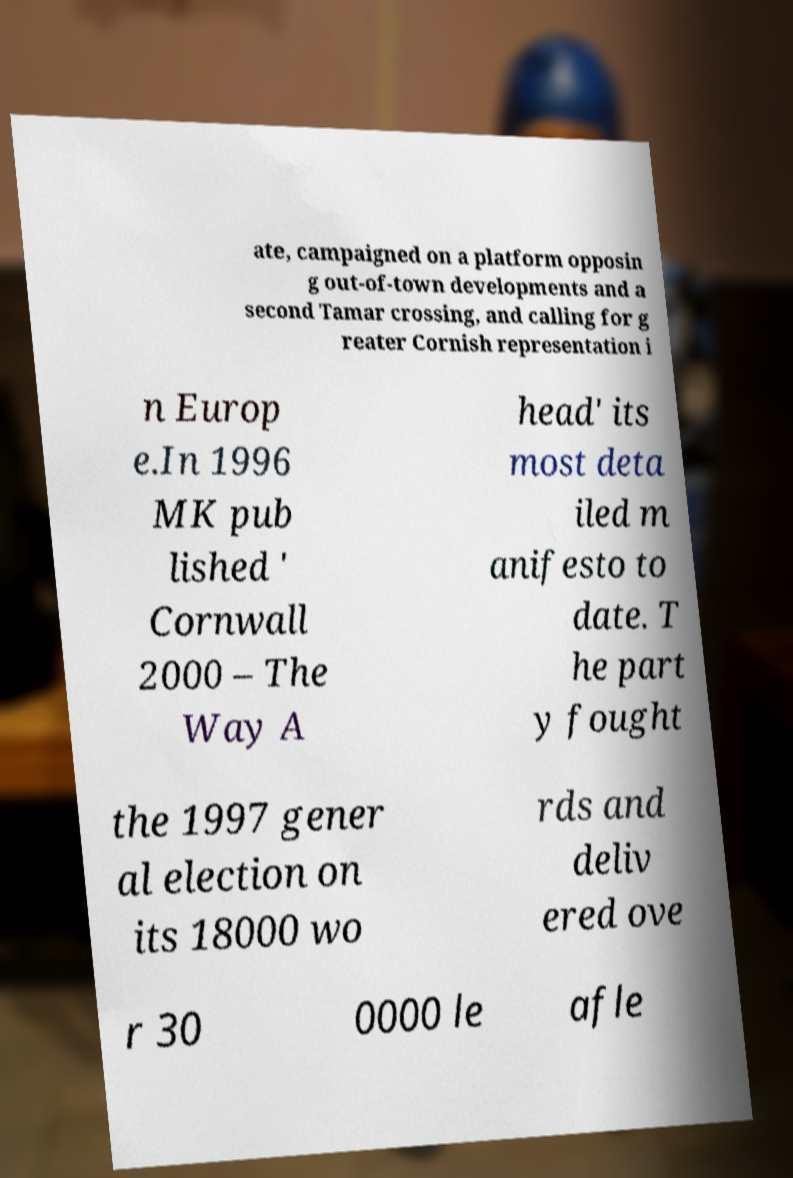Can you accurately transcribe the text from the provided image for me? ate, campaigned on a platform opposin g out-of-town developments and a second Tamar crossing, and calling for g reater Cornish representation i n Europ e.In 1996 MK pub lished ' Cornwall 2000 – The Way A head' its most deta iled m anifesto to date. T he part y fought the 1997 gener al election on its 18000 wo rds and deliv ered ove r 30 0000 le afle 